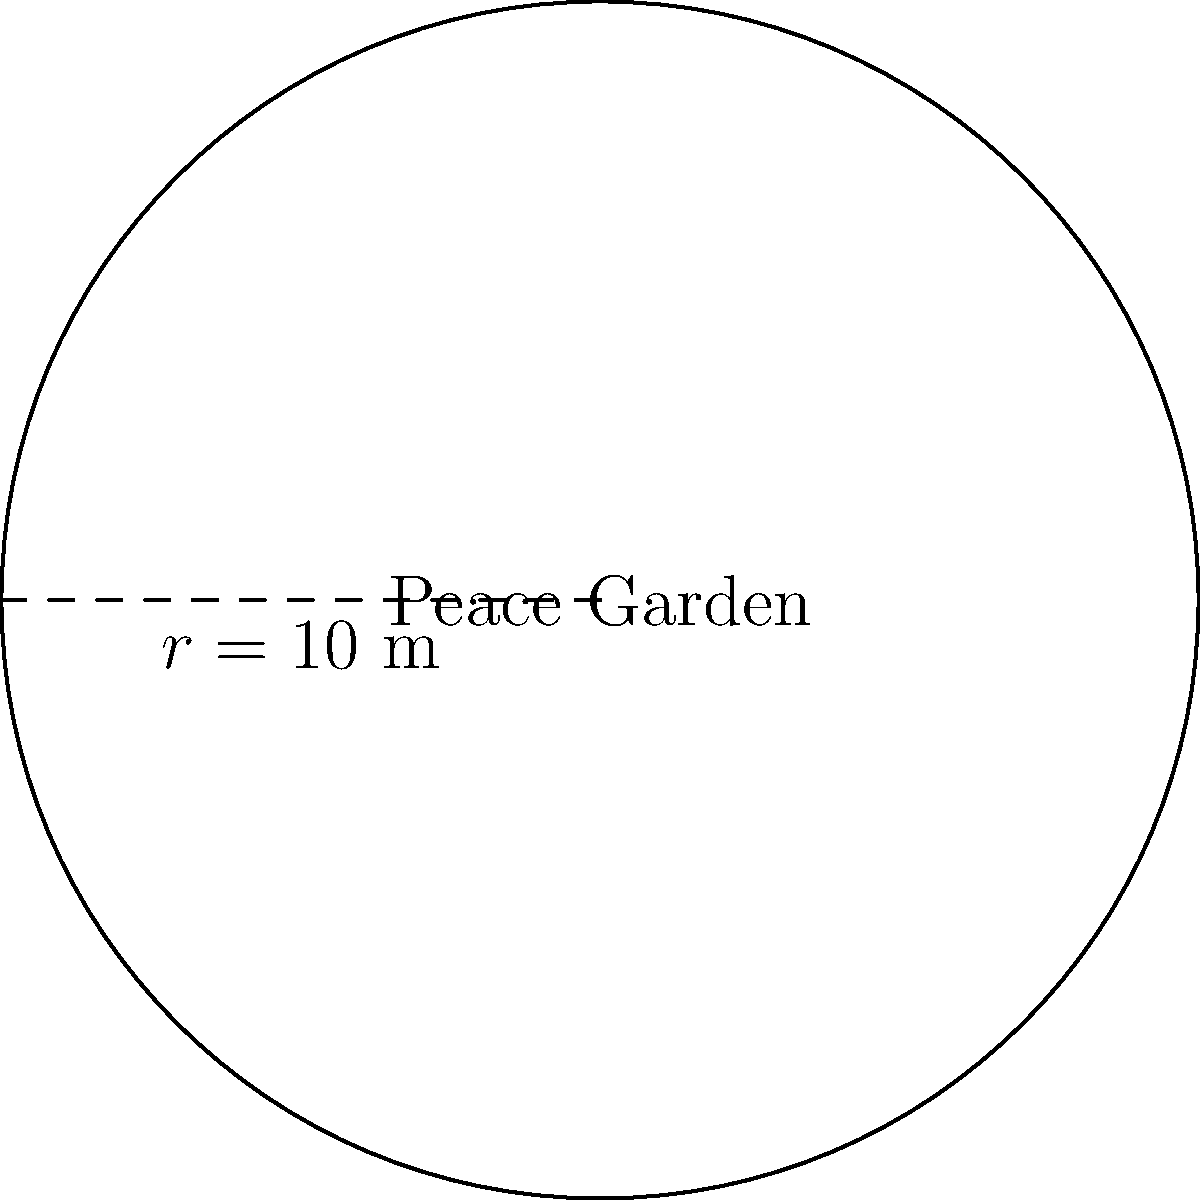In our university, we're planning to create a circular peace garden as a memorial for those affected by World War II. If the radius of the garden is 10 meters, what will be its area? To find the area of a circular garden, we need to use the formula for the area of a circle:

$$ A = \pi r^2 $$

Where:
$A$ is the area
$\pi$ (pi) is approximately 3.14159
$r$ is the radius

Given:
Radius ($r$) = 10 meters

Step 1: Substitute the values into the formula
$$ A = \pi (10)^2 $$

Step 2: Calculate the square of the radius
$$ A = \pi (100) $$

Step 3: Multiply by π
$$ A = 314.159 \text{ m}^2 $$

Therefore, the area of the peace garden will be approximately 314.159 square meters.
Answer: $314.159 \text{ m}^2$ 